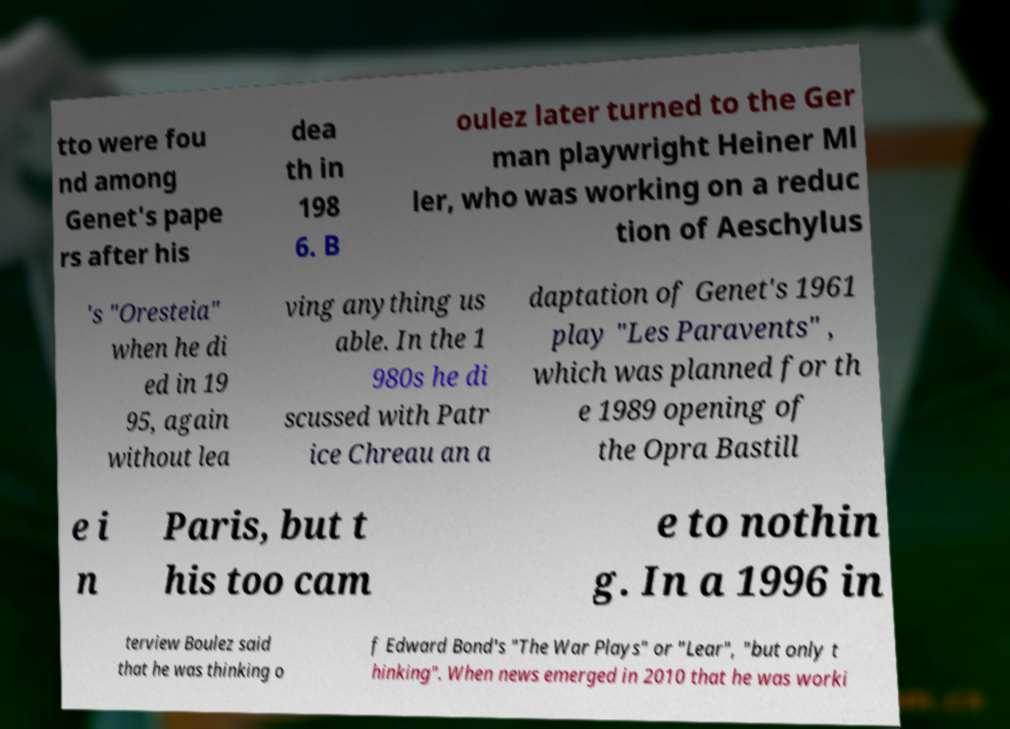Could you assist in decoding the text presented in this image and type it out clearly? tto were fou nd among Genet's pape rs after his dea th in 198 6. B oulez later turned to the Ger man playwright Heiner Ml ler, who was working on a reduc tion of Aeschylus 's "Oresteia" when he di ed in 19 95, again without lea ving anything us able. In the 1 980s he di scussed with Patr ice Chreau an a daptation of Genet's 1961 play "Les Paravents" , which was planned for th e 1989 opening of the Opra Bastill e i n Paris, but t his too cam e to nothin g. In a 1996 in terview Boulez said that he was thinking o f Edward Bond's "The War Plays" or "Lear", "but only t hinking". When news emerged in 2010 that he was worki 